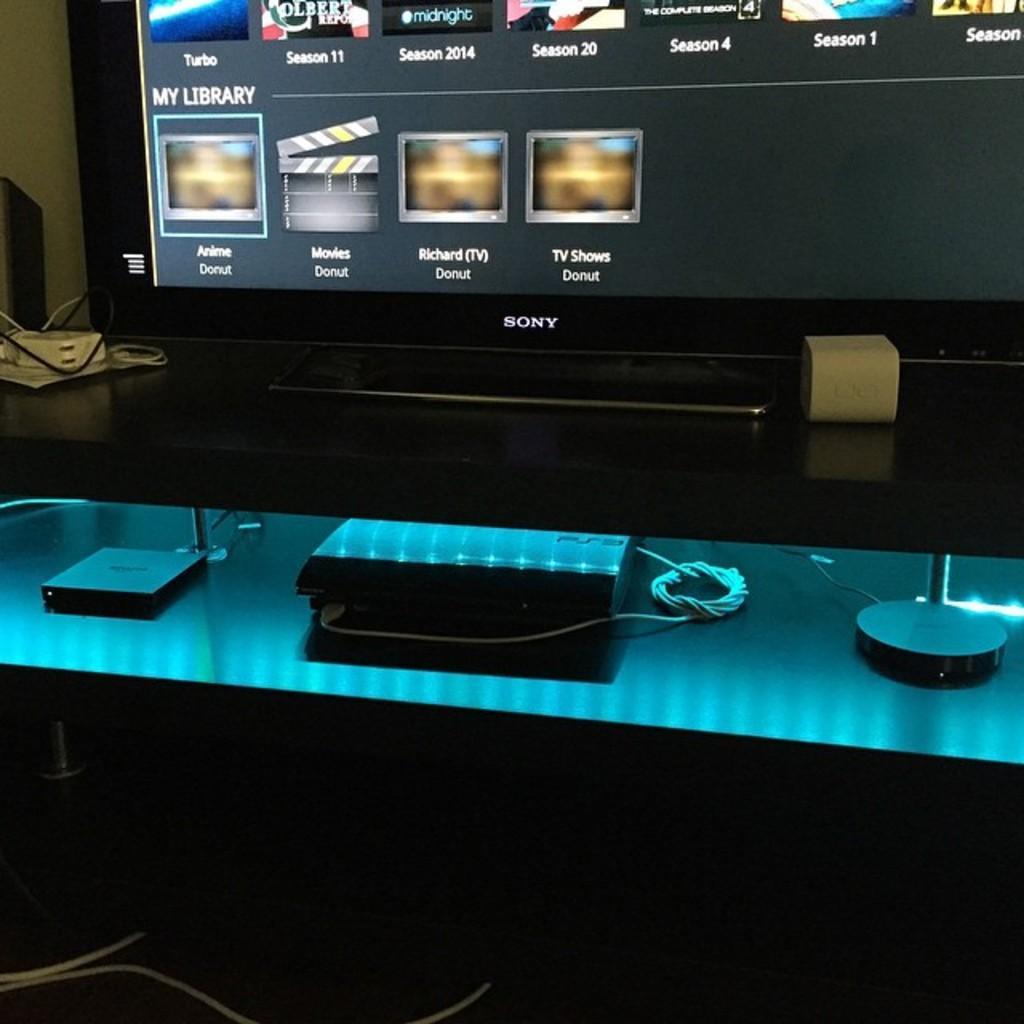Describe this image in one or two sentences. In this image I can see a black colored desk and on the desk I can see a television screen which is black in color , a extension box and few wires. Below the desk I can see few electronic gadgets and few wires. I can see few wires on the floor and the cream colored wall. 